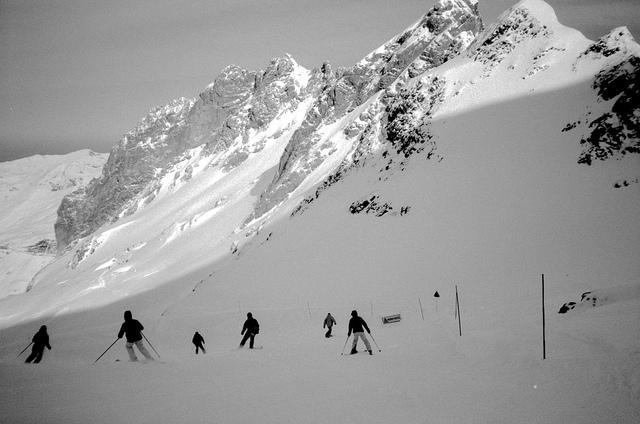Could this location be dangerous?
Be succinct. Yes. Is this a sunny day?
Keep it brief. Yes. How many people are skiing?
Write a very short answer. 6. What are the people doing on the snow?
Keep it brief. Skiing. 